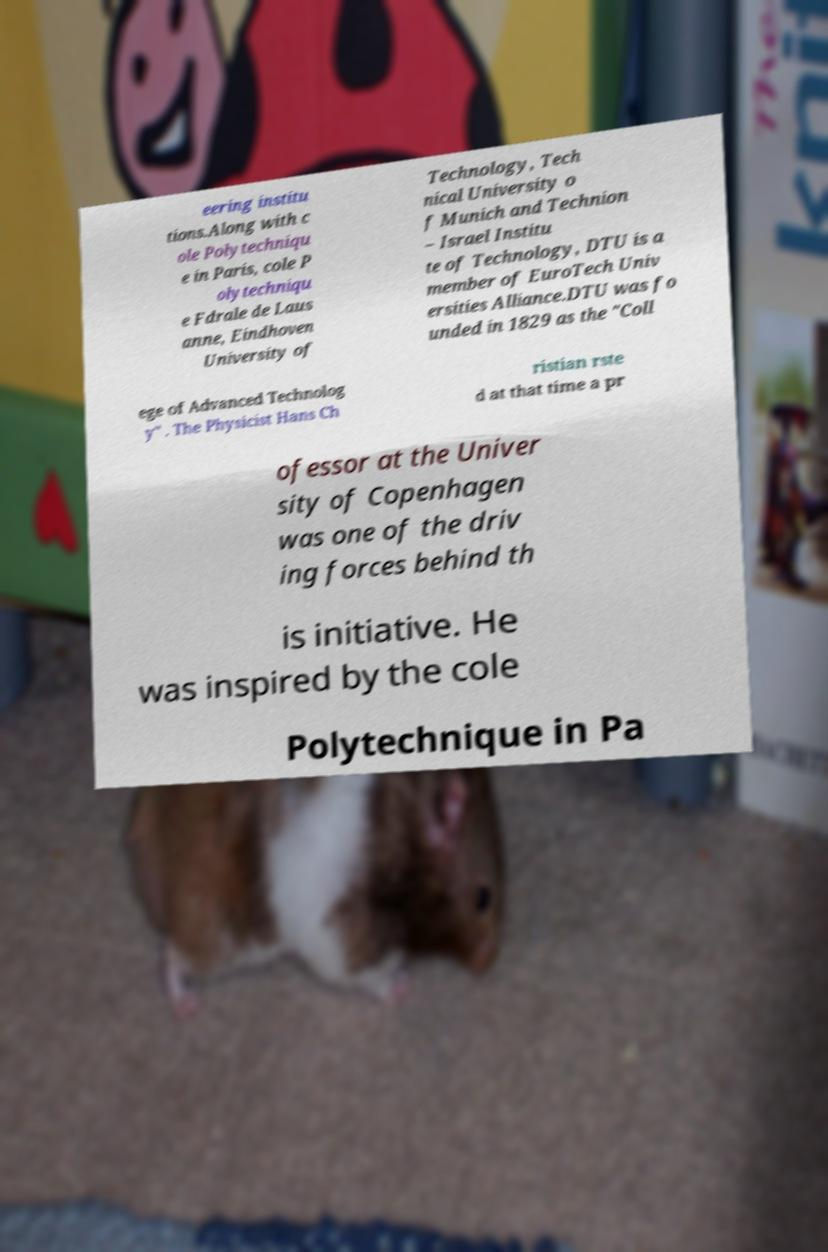Can you accurately transcribe the text from the provided image for me? eering institu tions.Along with c ole Polytechniqu e in Paris, cole P olytechniqu e Fdrale de Laus anne, Eindhoven University of Technology, Tech nical University o f Munich and Technion – Israel Institu te of Technology, DTU is a member of EuroTech Univ ersities Alliance.DTU was fo unded in 1829 as the "Coll ege of Advanced Technolog y" . The Physicist Hans Ch ristian rste d at that time a pr ofessor at the Univer sity of Copenhagen was one of the driv ing forces behind th is initiative. He was inspired by the cole Polytechnique in Pa 